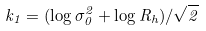<formula> <loc_0><loc_0><loc_500><loc_500>k _ { 1 } = ( \log \sigma _ { 0 } ^ { 2 } + \log R _ { h } ) / \sqrt { 2 }</formula> 